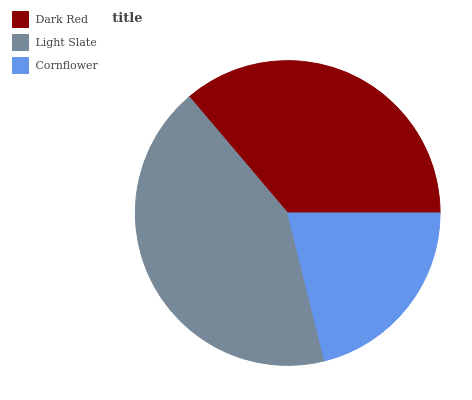Is Cornflower the minimum?
Answer yes or no. Yes. Is Light Slate the maximum?
Answer yes or no. Yes. Is Light Slate the minimum?
Answer yes or no. No. Is Cornflower the maximum?
Answer yes or no. No. Is Light Slate greater than Cornflower?
Answer yes or no. Yes. Is Cornflower less than Light Slate?
Answer yes or no. Yes. Is Cornflower greater than Light Slate?
Answer yes or no. No. Is Light Slate less than Cornflower?
Answer yes or no. No. Is Dark Red the high median?
Answer yes or no. Yes. Is Dark Red the low median?
Answer yes or no. Yes. Is Light Slate the high median?
Answer yes or no. No. Is Cornflower the low median?
Answer yes or no. No. 